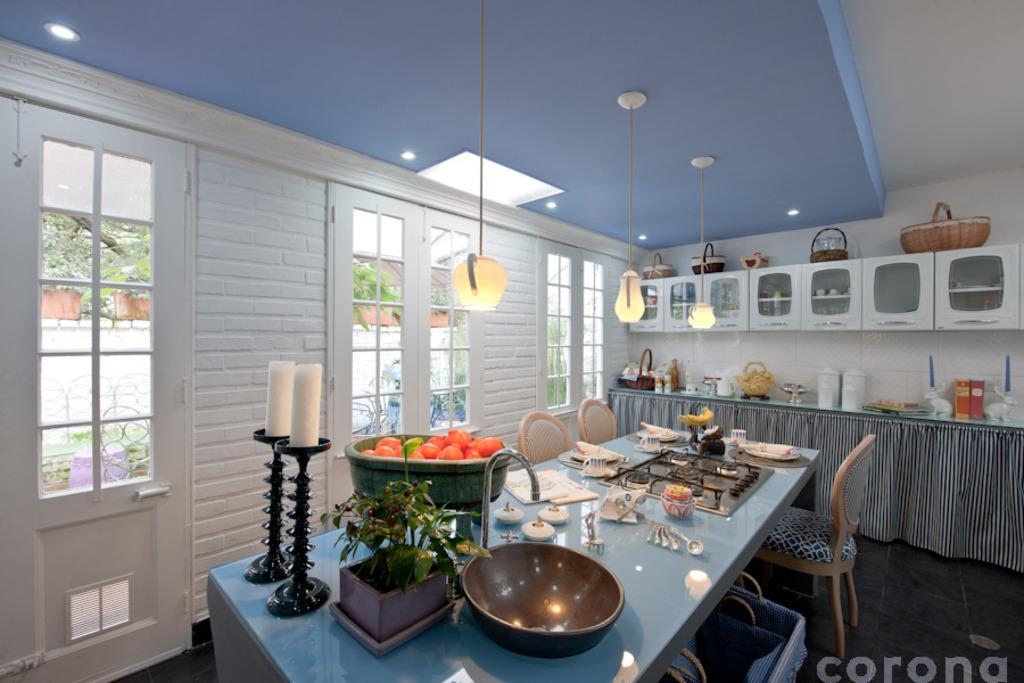What type of furniture is present in the image? There are chairs and tables in the image. What might be placed on the tables? There are things on the tables in the image. What type of storage units are present in the image? There are cabinets in the image. What can be seen through the windows in the image? There are windows in the image. How can people enter or exit the room in the image? There is a door in the image. What provides illumination in the image? There are lights visible in the image. What type of punishment is being administered in the image? There is no punishment being administered in the image; it only shows furniture, storage units, windows, a door, and lights. What type of coil is present in the image? There is no coil present in the image. 